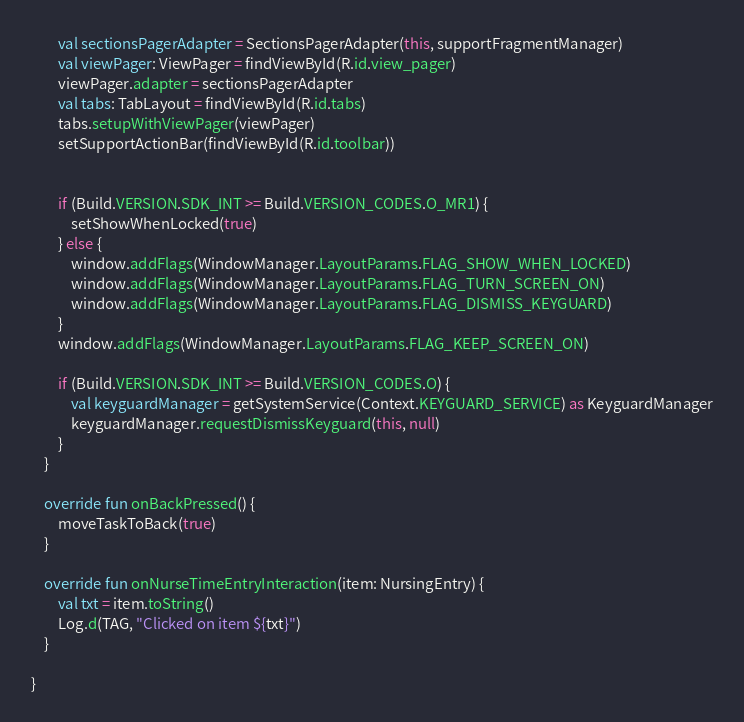<code> <loc_0><loc_0><loc_500><loc_500><_Kotlin_>        val sectionsPagerAdapter = SectionsPagerAdapter(this, supportFragmentManager)
        val viewPager: ViewPager = findViewById(R.id.view_pager)
        viewPager.adapter = sectionsPagerAdapter
        val tabs: TabLayout = findViewById(R.id.tabs)
        tabs.setupWithViewPager(viewPager)
        setSupportActionBar(findViewById(R.id.toolbar))


        if (Build.VERSION.SDK_INT >= Build.VERSION_CODES.O_MR1) {
            setShowWhenLocked(true)
        } else {
            window.addFlags(WindowManager.LayoutParams.FLAG_SHOW_WHEN_LOCKED)
            window.addFlags(WindowManager.LayoutParams.FLAG_TURN_SCREEN_ON)
            window.addFlags(WindowManager.LayoutParams.FLAG_DISMISS_KEYGUARD)
        }
        window.addFlags(WindowManager.LayoutParams.FLAG_KEEP_SCREEN_ON)

        if (Build.VERSION.SDK_INT >= Build.VERSION_CODES.O) {
            val keyguardManager = getSystemService(Context.KEYGUARD_SERVICE) as KeyguardManager
            keyguardManager.requestDismissKeyguard(this, null)
        }
    }

    override fun onBackPressed() {
        moveTaskToBack(true)
    }

    override fun onNurseTimeEntryInteraction(item: NursingEntry) {
        val txt = item.toString()
        Log.d(TAG, "Clicked on item ${txt}")
    }

}</code> 